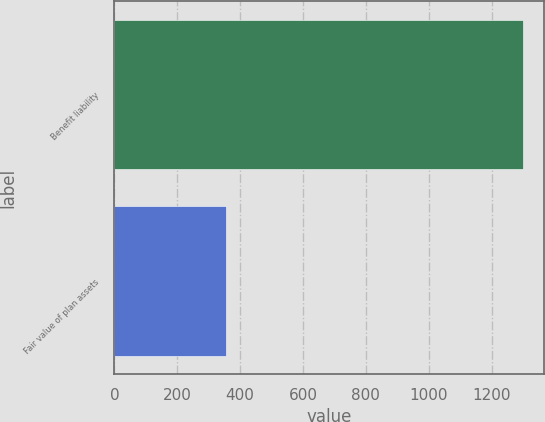Convert chart. <chart><loc_0><loc_0><loc_500><loc_500><bar_chart><fcel>Benefit liability<fcel>Fair value of plan assets<nl><fcel>1300<fcel>354<nl></chart> 